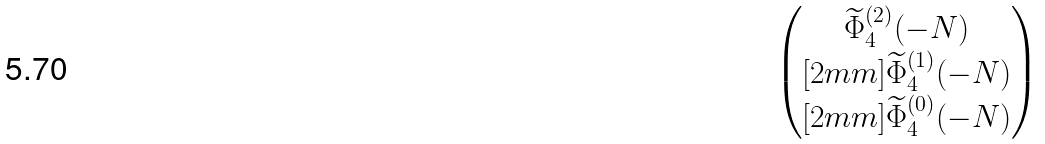Convert formula to latex. <formula><loc_0><loc_0><loc_500><loc_500>\begin{pmatrix} \widetilde { \Phi } _ { 4 } ^ { ( 2 ) } ( - N ) \\ [ 2 m m ] \widetilde { \Phi } _ { 4 } ^ { ( 1 ) } ( - N ) \\ [ 2 m m ] \widetilde { \Phi } _ { 4 } ^ { ( 0 ) } ( - N ) \end{pmatrix}</formula> 